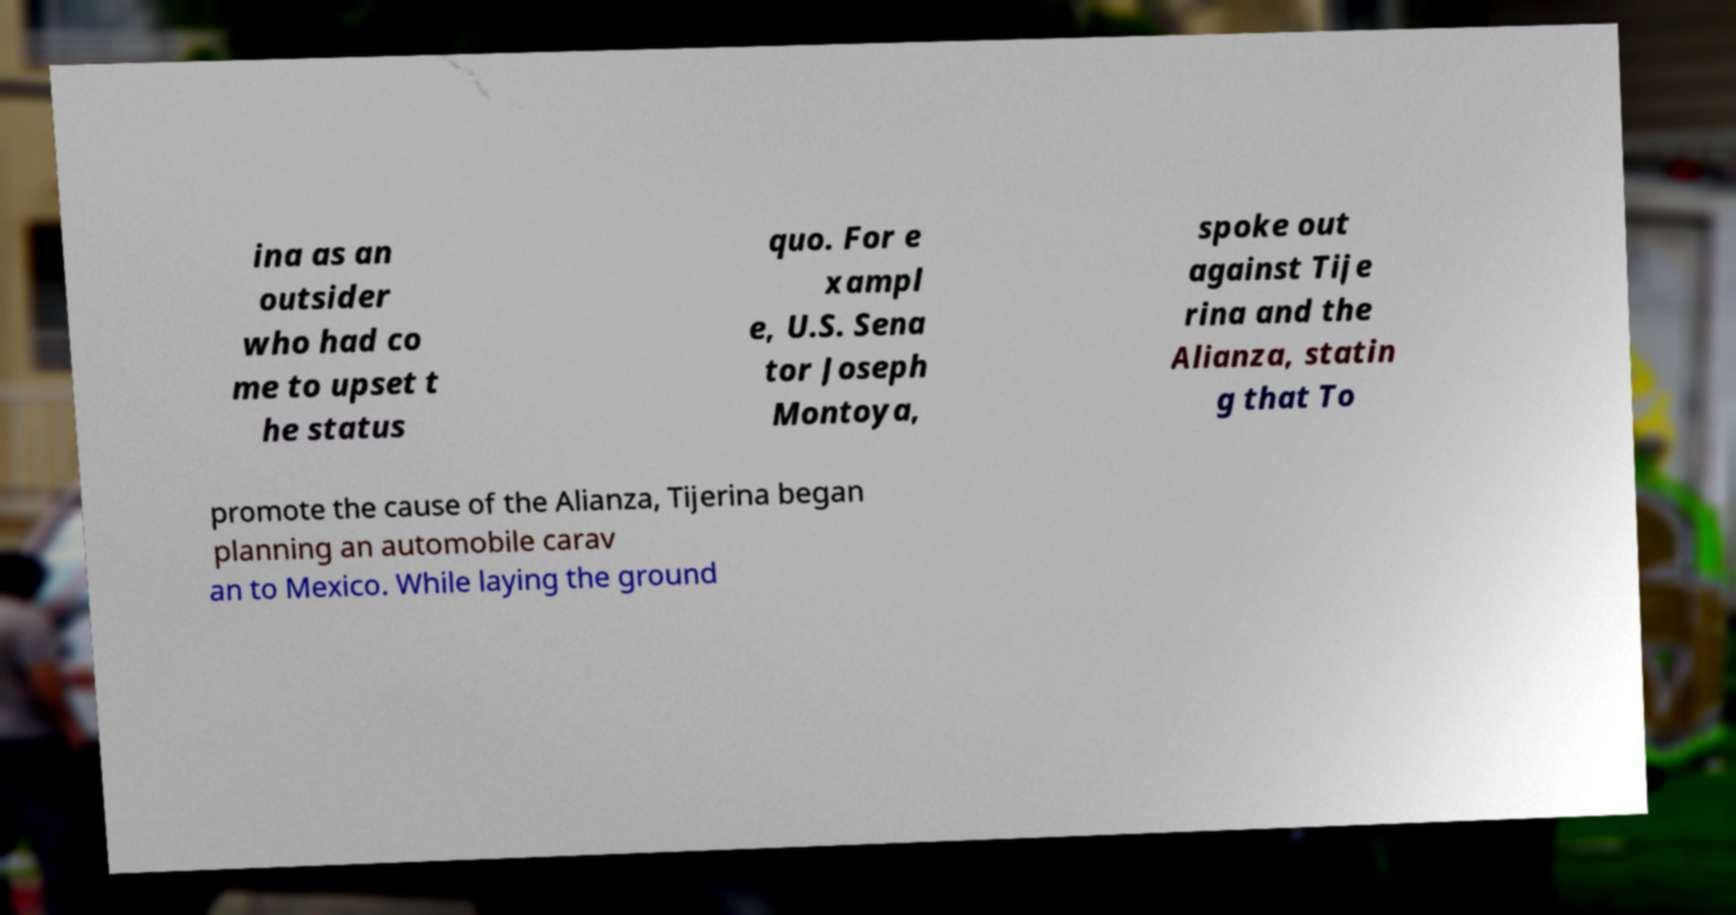Could you assist in decoding the text presented in this image and type it out clearly? ina as an outsider who had co me to upset t he status quo. For e xampl e, U.S. Sena tor Joseph Montoya, spoke out against Tije rina and the Alianza, statin g that To promote the cause of the Alianza, Tijerina began planning an automobile carav an to Mexico. While laying the ground 